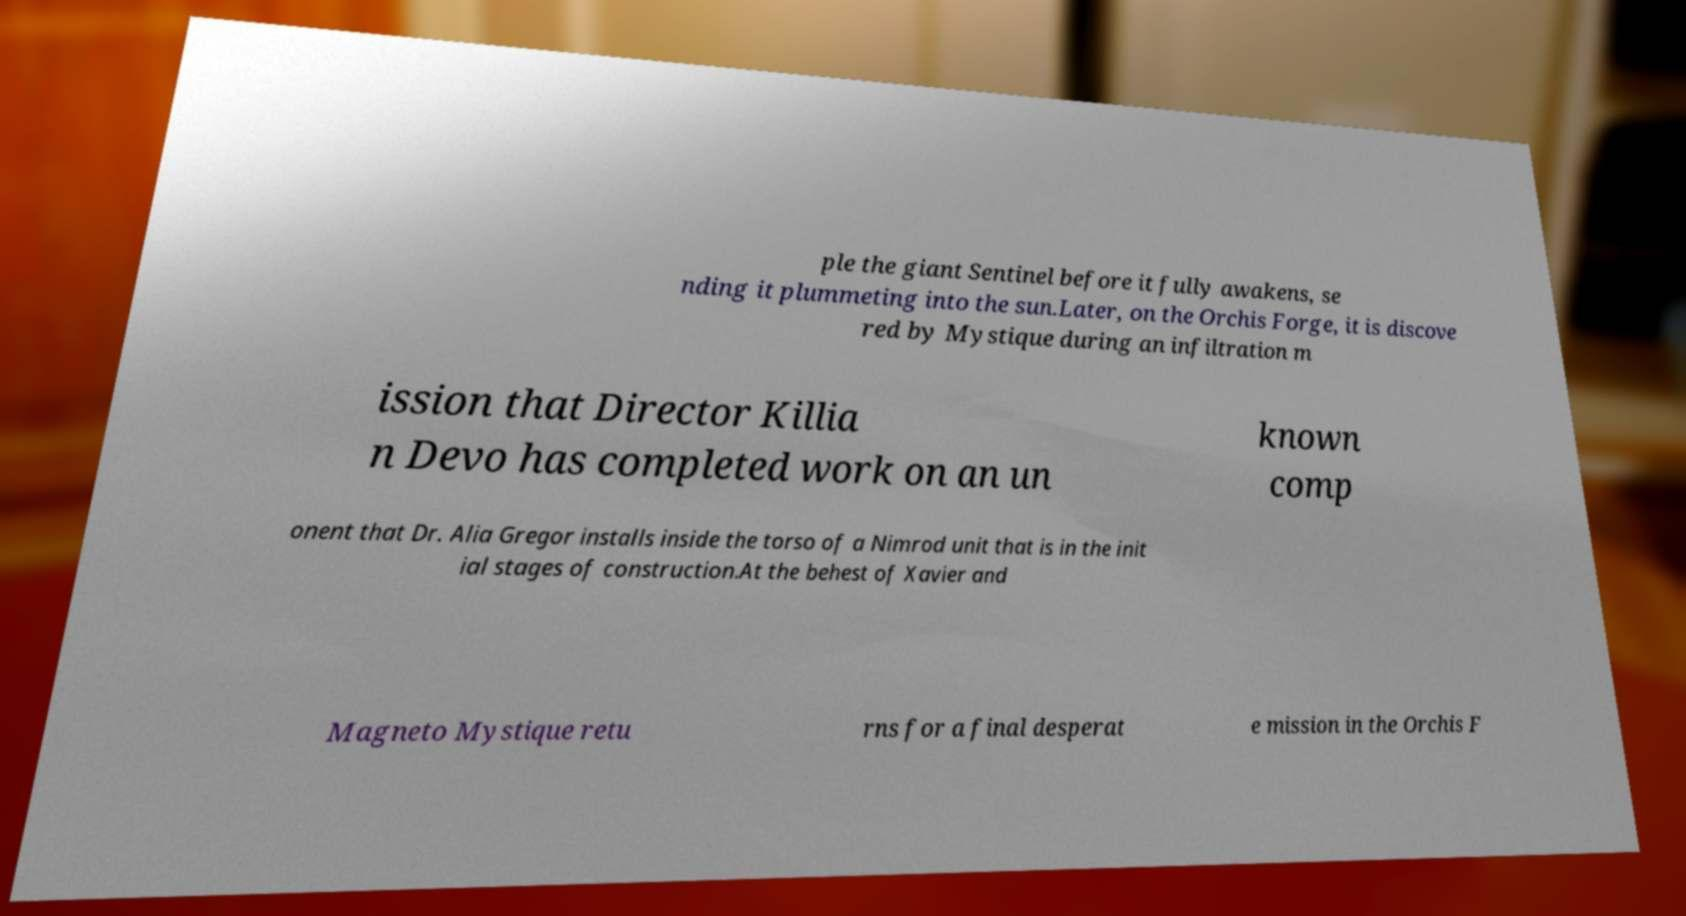Could you extract and type out the text from this image? ple the giant Sentinel before it fully awakens, se nding it plummeting into the sun.Later, on the Orchis Forge, it is discove red by Mystique during an infiltration m ission that Director Killia n Devo has completed work on an un known comp onent that Dr. Alia Gregor installs inside the torso of a Nimrod unit that is in the init ial stages of construction.At the behest of Xavier and Magneto Mystique retu rns for a final desperat e mission in the Orchis F 